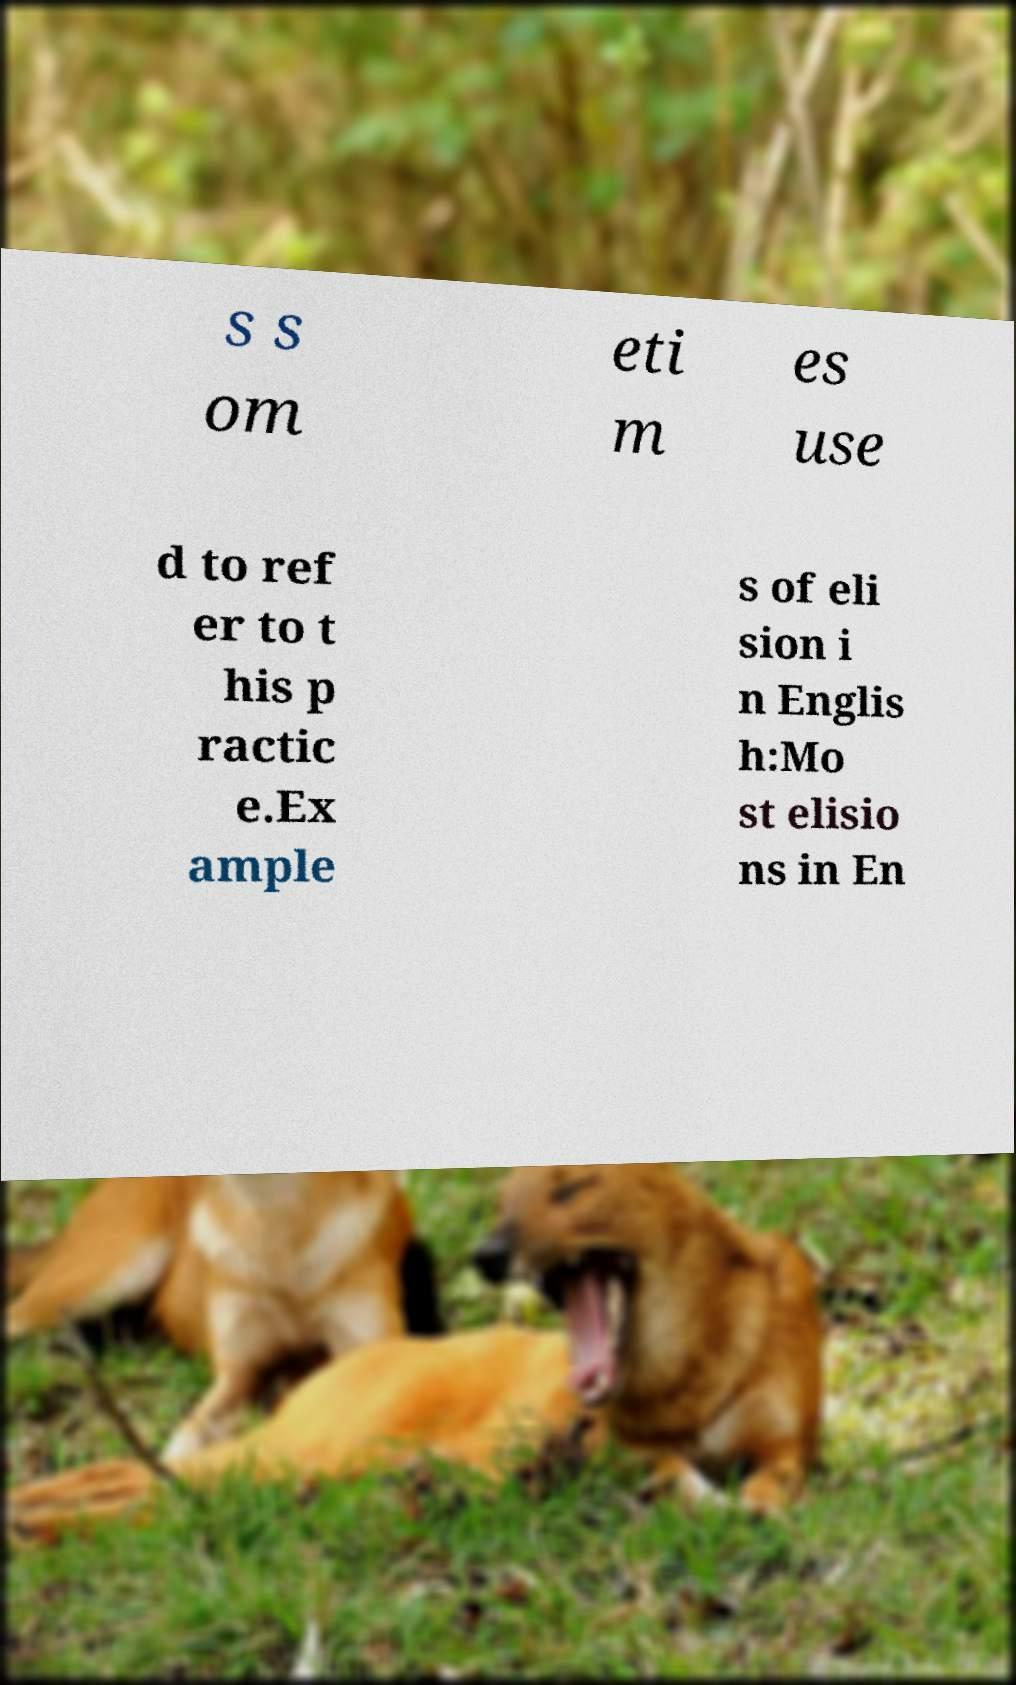Can you read and provide the text displayed in the image?This photo seems to have some interesting text. Can you extract and type it out for me? s s om eti m es use d to ref er to t his p ractic e.Ex ample s of eli sion i n Englis h:Mo st elisio ns in En 